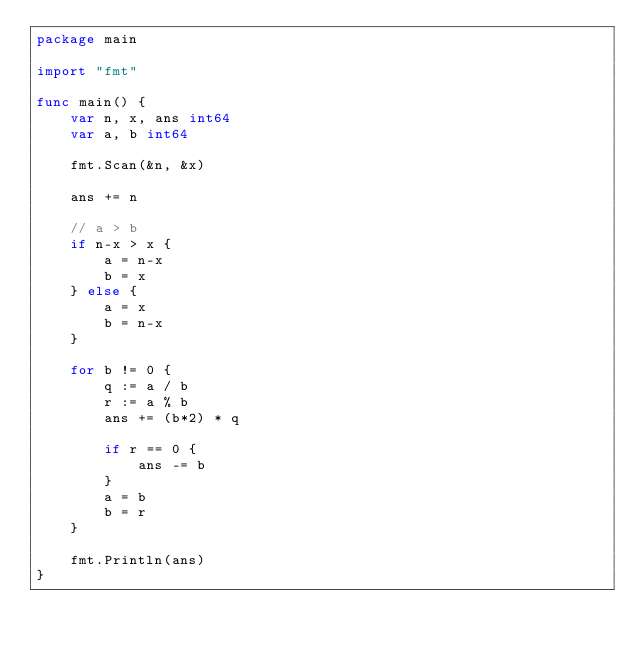Convert code to text. <code><loc_0><loc_0><loc_500><loc_500><_Go_>package main

import "fmt"

func main() {
    var n, x, ans int64
    var a, b int64

    fmt.Scan(&n, &x)

    ans += n

    // a > b
    if n-x > x {
        a = n-x
        b = x
    } else {
        a = x
        b = n-x
    }

    for b != 0 {
        q := a / b
        r := a % b
        ans += (b*2) * q

        if r == 0 {
            ans -= b
        }
        a = b
        b = r
    }

    fmt.Println(ans)
}</code> 